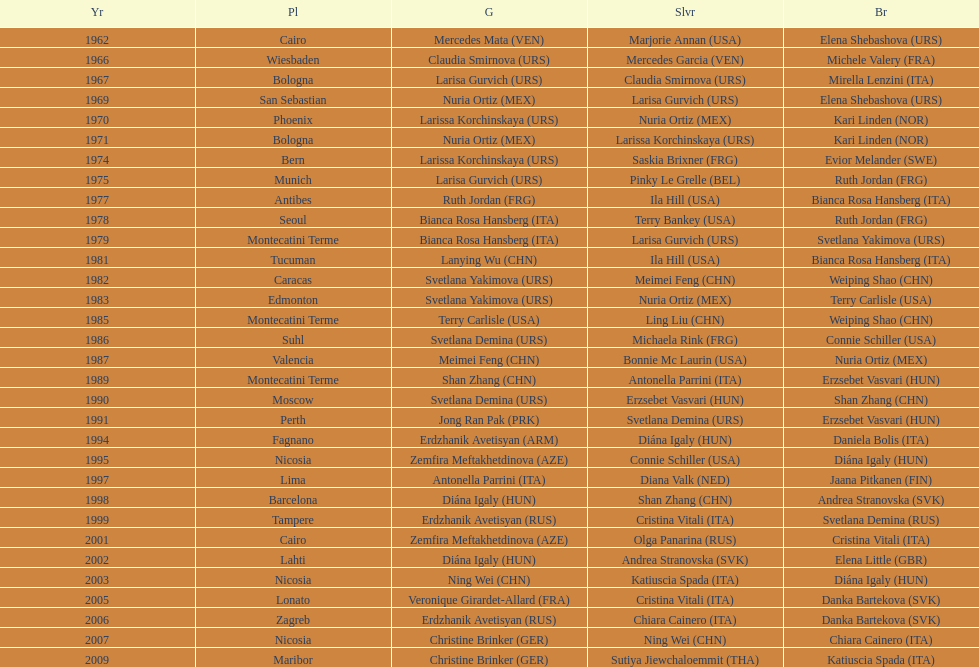What is the aggregate number of wins for the united states in gold, silver, and bronze? 9. 